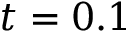<formula> <loc_0><loc_0><loc_500><loc_500>t = 0 . 1</formula> 